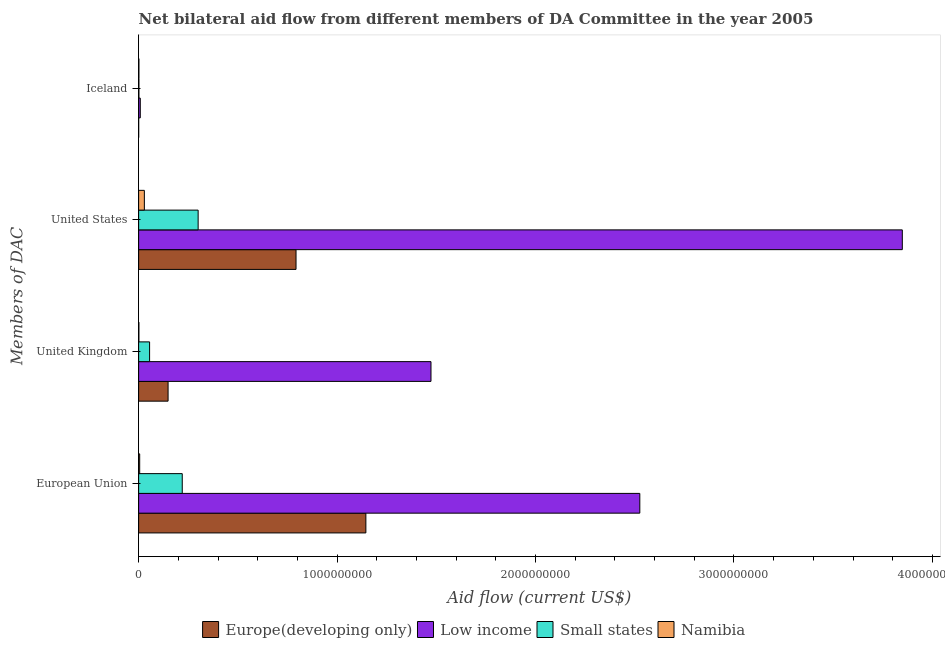What is the amount of aid given by eu in Europe(developing only)?
Offer a very short reply. 1.15e+09. Across all countries, what is the maximum amount of aid given by eu?
Keep it short and to the point. 2.53e+09. Across all countries, what is the minimum amount of aid given by uk?
Provide a short and direct response. 1.29e+06. In which country was the amount of aid given by iceland maximum?
Your answer should be very brief. Low income. In which country was the amount of aid given by eu minimum?
Offer a terse response. Namibia. What is the total amount of aid given by us in the graph?
Ensure brevity in your answer.  4.97e+09. What is the difference between the amount of aid given by us in Namibia and that in Europe(developing only)?
Give a very brief answer. -7.64e+08. What is the difference between the amount of aid given by us in Namibia and the amount of aid given by iceland in Low income?
Offer a very short reply. 2.06e+07. What is the average amount of aid given by us per country?
Make the answer very short. 1.24e+09. What is the difference between the amount of aid given by eu and amount of aid given by us in Namibia?
Make the answer very short. -2.36e+07. What is the ratio of the amount of aid given by us in Europe(developing only) to that in Low income?
Your answer should be very brief. 0.21. What is the difference between the highest and the second highest amount of aid given by eu?
Ensure brevity in your answer.  1.38e+09. What is the difference between the highest and the lowest amount of aid given by uk?
Offer a terse response. 1.47e+09. Is the sum of the amount of aid given by eu in Low income and Small states greater than the maximum amount of aid given by uk across all countries?
Provide a short and direct response. Yes. Is it the case that in every country, the sum of the amount of aid given by eu and amount of aid given by uk is greater than the sum of amount of aid given by iceland and amount of aid given by us?
Your answer should be very brief. No. What does the 1st bar from the top in European Union represents?
Your answer should be very brief. Namibia. What does the 4th bar from the bottom in United Kingdom represents?
Your response must be concise. Namibia. Is it the case that in every country, the sum of the amount of aid given by eu and amount of aid given by uk is greater than the amount of aid given by us?
Provide a short and direct response. No. How many bars are there?
Provide a succinct answer. 16. What is the difference between two consecutive major ticks on the X-axis?
Your answer should be compact. 1.00e+09. Are the values on the major ticks of X-axis written in scientific E-notation?
Provide a short and direct response. No. Where does the legend appear in the graph?
Your response must be concise. Bottom center. How many legend labels are there?
Your answer should be compact. 4. What is the title of the graph?
Your answer should be very brief. Net bilateral aid flow from different members of DA Committee in the year 2005. What is the label or title of the X-axis?
Your answer should be very brief. Aid flow (current US$). What is the label or title of the Y-axis?
Keep it short and to the point. Members of DAC. What is the Aid flow (current US$) in Europe(developing only) in European Union?
Your answer should be compact. 1.15e+09. What is the Aid flow (current US$) in Low income in European Union?
Provide a succinct answer. 2.53e+09. What is the Aid flow (current US$) in Small states in European Union?
Keep it short and to the point. 2.20e+08. What is the Aid flow (current US$) of Namibia in European Union?
Your answer should be very brief. 5.31e+06. What is the Aid flow (current US$) in Europe(developing only) in United Kingdom?
Make the answer very short. 1.48e+08. What is the Aid flow (current US$) in Low income in United Kingdom?
Keep it short and to the point. 1.47e+09. What is the Aid flow (current US$) of Small states in United Kingdom?
Provide a short and direct response. 5.53e+07. What is the Aid flow (current US$) of Namibia in United Kingdom?
Your answer should be very brief. 1.29e+06. What is the Aid flow (current US$) in Europe(developing only) in United States?
Ensure brevity in your answer.  7.93e+08. What is the Aid flow (current US$) in Low income in United States?
Your answer should be very brief. 3.85e+09. What is the Aid flow (current US$) in Small states in United States?
Offer a very short reply. 3.00e+08. What is the Aid flow (current US$) of Namibia in United States?
Offer a terse response. 2.89e+07. What is the Aid flow (current US$) in Europe(developing only) in Iceland?
Offer a terse response. 2.20e+05. What is the Aid flow (current US$) in Low income in Iceland?
Offer a terse response. 8.29e+06. What is the Aid flow (current US$) of Small states in Iceland?
Keep it short and to the point. 1.36e+06. What is the Aid flow (current US$) in Namibia in Iceland?
Keep it short and to the point. 1.36e+06. Across all Members of DAC, what is the maximum Aid flow (current US$) of Europe(developing only)?
Ensure brevity in your answer.  1.15e+09. Across all Members of DAC, what is the maximum Aid flow (current US$) in Low income?
Provide a short and direct response. 3.85e+09. Across all Members of DAC, what is the maximum Aid flow (current US$) of Small states?
Keep it short and to the point. 3.00e+08. Across all Members of DAC, what is the maximum Aid flow (current US$) of Namibia?
Ensure brevity in your answer.  2.89e+07. Across all Members of DAC, what is the minimum Aid flow (current US$) of Europe(developing only)?
Provide a succinct answer. 2.20e+05. Across all Members of DAC, what is the minimum Aid flow (current US$) in Low income?
Your answer should be very brief. 8.29e+06. Across all Members of DAC, what is the minimum Aid flow (current US$) in Small states?
Offer a terse response. 1.36e+06. Across all Members of DAC, what is the minimum Aid flow (current US$) in Namibia?
Ensure brevity in your answer.  1.29e+06. What is the total Aid flow (current US$) of Europe(developing only) in the graph?
Your answer should be compact. 2.09e+09. What is the total Aid flow (current US$) of Low income in the graph?
Provide a short and direct response. 7.86e+09. What is the total Aid flow (current US$) of Small states in the graph?
Keep it short and to the point. 5.76e+08. What is the total Aid flow (current US$) in Namibia in the graph?
Ensure brevity in your answer.  3.68e+07. What is the difference between the Aid flow (current US$) in Europe(developing only) in European Union and that in United Kingdom?
Your answer should be very brief. 9.97e+08. What is the difference between the Aid flow (current US$) in Low income in European Union and that in United Kingdom?
Keep it short and to the point. 1.05e+09. What is the difference between the Aid flow (current US$) in Small states in European Union and that in United Kingdom?
Offer a terse response. 1.65e+08. What is the difference between the Aid flow (current US$) in Namibia in European Union and that in United Kingdom?
Provide a succinct answer. 4.02e+06. What is the difference between the Aid flow (current US$) of Europe(developing only) in European Union and that in United States?
Keep it short and to the point. 3.52e+08. What is the difference between the Aid flow (current US$) of Low income in European Union and that in United States?
Make the answer very short. -1.32e+09. What is the difference between the Aid flow (current US$) of Small states in European Union and that in United States?
Ensure brevity in your answer.  -8.01e+07. What is the difference between the Aid flow (current US$) in Namibia in European Union and that in United States?
Provide a succinct answer. -2.36e+07. What is the difference between the Aid flow (current US$) of Europe(developing only) in European Union and that in Iceland?
Ensure brevity in your answer.  1.14e+09. What is the difference between the Aid flow (current US$) of Low income in European Union and that in Iceland?
Provide a short and direct response. 2.52e+09. What is the difference between the Aid flow (current US$) in Small states in European Union and that in Iceland?
Your answer should be very brief. 2.18e+08. What is the difference between the Aid flow (current US$) of Namibia in European Union and that in Iceland?
Keep it short and to the point. 3.95e+06. What is the difference between the Aid flow (current US$) of Europe(developing only) in United Kingdom and that in United States?
Your answer should be compact. -6.45e+08. What is the difference between the Aid flow (current US$) in Low income in United Kingdom and that in United States?
Provide a succinct answer. -2.38e+09. What is the difference between the Aid flow (current US$) in Small states in United Kingdom and that in United States?
Keep it short and to the point. -2.45e+08. What is the difference between the Aid flow (current US$) in Namibia in United Kingdom and that in United States?
Provide a short and direct response. -2.76e+07. What is the difference between the Aid flow (current US$) of Europe(developing only) in United Kingdom and that in Iceland?
Make the answer very short. 1.48e+08. What is the difference between the Aid flow (current US$) in Low income in United Kingdom and that in Iceland?
Offer a very short reply. 1.46e+09. What is the difference between the Aid flow (current US$) in Small states in United Kingdom and that in Iceland?
Your answer should be very brief. 5.39e+07. What is the difference between the Aid flow (current US$) in Namibia in United Kingdom and that in Iceland?
Provide a succinct answer. -7.00e+04. What is the difference between the Aid flow (current US$) in Europe(developing only) in United States and that in Iceland?
Give a very brief answer. 7.93e+08. What is the difference between the Aid flow (current US$) of Low income in United States and that in Iceland?
Offer a terse response. 3.84e+09. What is the difference between the Aid flow (current US$) in Small states in United States and that in Iceland?
Provide a succinct answer. 2.99e+08. What is the difference between the Aid flow (current US$) in Namibia in United States and that in Iceland?
Keep it short and to the point. 2.75e+07. What is the difference between the Aid flow (current US$) of Europe(developing only) in European Union and the Aid flow (current US$) of Low income in United Kingdom?
Your response must be concise. -3.28e+08. What is the difference between the Aid flow (current US$) in Europe(developing only) in European Union and the Aid flow (current US$) in Small states in United Kingdom?
Offer a terse response. 1.09e+09. What is the difference between the Aid flow (current US$) of Europe(developing only) in European Union and the Aid flow (current US$) of Namibia in United Kingdom?
Offer a very short reply. 1.14e+09. What is the difference between the Aid flow (current US$) in Low income in European Union and the Aid flow (current US$) in Small states in United Kingdom?
Provide a succinct answer. 2.47e+09. What is the difference between the Aid flow (current US$) of Low income in European Union and the Aid flow (current US$) of Namibia in United Kingdom?
Offer a very short reply. 2.52e+09. What is the difference between the Aid flow (current US$) of Small states in European Union and the Aid flow (current US$) of Namibia in United Kingdom?
Provide a short and direct response. 2.19e+08. What is the difference between the Aid flow (current US$) of Europe(developing only) in European Union and the Aid flow (current US$) of Low income in United States?
Offer a terse response. -2.70e+09. What is the difference between the Aid flow (current US$) of Europe(developing only) in European Union and the Aid flow (current US$) of Small states in United States?
Offer a very short reply. 8.45e+08. What is the difference between the Aid flow (current US$) of Europe(developing only) in European Union and the Aid flow (current US$) of Namibia in United States?
Offer a very short reply. 1.12e+09. What is the difference between the Aid flow (current US$) in Low income in European Union and the Aid flow (current US$) in Small states in United States?
Provide a short and direct response. 2.23e+09. What is the difference between the Aid flow (current US$) of Low income in European Union and the Aid flow (current US$) of Namibia in United States?
Make the answer very short. 2.50e+09. What is the difference between the Aid flow (current US$) of Small states in European Union and the Aid flow (current US$) of Namibia in United States?
Ensure brevity in your answer.  1.91e+08. What is the difference between the Aid flow (current US$) in Europe(developing only) in European Union and the Aid flow (current US$) in Low income in Iceland?
Provide a short and direct response. 1.14e+09. What is the difference between the Aid flow (current US$) of Europe(developing only) in European Union and the Aid flow (current US$) of Small states in Iceland?
Keep it short and to the point. 1.14e+09. What is the difference between the Aid flow (current US$) in Europe(developing only) in European Union and the Aid flow (current US$) in Namibia in Iceland?
Give a very brief answer. 1.14e+09. What is the difference between the Aid flow (current US$) of Low income in European Union and the Aid flow (current US$) of Small states in Iceland?
Provide a short and direct response. 2.52e+09. What is the difference between the Aid flow (current US$) of Low income in European Union and the Aid flow (current US$) of Namibia in Iceland?
Your response must be concise. 2.52e+09. What is the difference between the Aid flow (current US$) of Small states in European Union and the Aid flow (current US$) of Namibia in Iceland?
Provide a succinct answer. 2.18e+08. What is the difference between the Aid flow (current US$) of Europe(developing only) in United Kingdom and the Aid flow (current US$) of Low income in United States?
Give a very brief answer. -3.70e+09. What is the difference between the Aid flow (current US$) in Europe(developing only) in United Kingdom and the Aid flow (current US$) in Small states in United States?
Keep it short and to the point. -1.52e+08. What is the difference between the Aid flow (current US$) in Europe(developing only) in United Kingdom and the Aid flow (current US$) in Namibia in United States?
Give a very brief answer. 1.20e+08. What is the difference between the Aid flow (current US$) of Low income in United Kingdom and the Aid flow (current US$) of Small states in United States?
Give a very brief answer. 1.17e+09. What is the difference between the Aid flow (current US$) in Low income in United Kingdom and the Aid flow (current US$) in Namibia in United States?
Ensure brevity in your answer.  1.44e+09. What is the difference between the Aid flow (current US$) in Small states in United Kingdom and the Aid flow (current US$) in Namibia in United States?
Offer a terse response. 2.64e+07. What is the difference between the Aid flow (current US$) of Europe(developing only) in United Kingdom and the Aid flow (current US$) of Low income in Iceland?
Your answer should be compact. 1.40e+08. What is the difference between the Aid flow (current US$) of Europe(developing only) in United Kingdom and the Aid flow (current US$) of Small states in Iceland?
Your response must be concise. 1.47e+08. What is the difference between the Aid flow (current US$) in Europe(developing only) in United Kingdom and the Aid flow (current US$) in Namibia in Iceland?
Your answer should be very brief. 1.47e+08. What is the difference between the Aid flow (current US$) of Low income in United Kingdom and the Aid flow (current US$) of Small states in Iceland?
Your response must be concise. 1.47e+09. What is the difference between the Aid flow (current US$) of Low income in United Kingdom and the Aid flow (current US$) of Namibia in Iceland?
Offer a terse response. 1.47e+09. What is the difference between the Aid flow (current US$) of Small states in United Kingdom and the Aid flow (current US$) of Namibia in Iceland?
Your answer should be very brief. 5.39e+07. What is the difference between the Aid flow (current US$) in Europe(developing only) in United States and the Aid flow (current US$) in Low income in Iceland?
Offer a terse response. 7.85e+08. What is the difference between the Aid flow (current US$) in Europe(developing only) in United States and the Aid flow (current US$) in Small states in Iceland?
Ensure brevity in your answer.  7.92e+08. What is the difference between the Aid flow (current US$) in Europe(developing only) in United States and the Aid flow (current US$) in Namibia in Iceland?
Offer a very short reply. 7.92e+08. What is the difference between the Aid flow (current US$) in Low income in United States and the Aid flow (current US$) in Small states in Iceland?
Your answer should be compact. 3.85e+09. What is the difference between the Aid flow (current US$) in Low income in United States and the Aid flow (current US$) in Namibia in Iceland?
Offer a terse response. 3.85e+09. What is the difference between the Aid flow (current US$) of Small states in United States and the Aid flow (current US$) of Namibia in Iceland?
Your answer should be very brief. 2.99e+08. What is the average Aid flow (current US$) of Europe(developing only) per Members of DAC?
Your answer should be compact. 5.22e+08. What is the average Aid flow (current US$) of Low income per Members of DAC?
Provide a succinct answer. 1.96e+09. What is the average Aid flow (current US$) of Small states per Members of DAC?
Provide a short and direct response. 1.44e+08. What is the average Aid flow (current US$) of Namibia per Members of DAC?
Provide a short and direct response. 9.21e+06. What is the difference between the Aid flow (current US$) of Europe(developing only) and Aid flow (current US$) of Low income in European Union?
Provide a short and direct response. -1.38e+09. What is the difference between the Aid flow (current US$) in Europe(developing only) and Aid flow (current US$) in Small states in European Union?
Offer a terse response. 9.25e+08. What is the difference between the Aid flow (current US$) of Europe(developing only) and Aid flow (current US$) of Namibia in European Union?
Your answer should be compact. 1.14e+09. What is the difference between the Aid flow (current US$) in Low income and Aid flow (current US$) in Small states in European Union?
Your answer should be very brief. 2.31e+09. What is the difference between the Aid flow (current US$) in Low income and Aid flow (current US$) in Namibia in European Union?
Provide a short and direct response. 2.52e+09. What is the difference between the Aid flow (current US$) in Small states and Aid flow (current US$) in Namibia in European Union?
Ensure brevity in your answer.  2.14e+08. What is the difference between the Aid flow (current US$) of Europe(developing only) and Aid flow (current US$) of Low income in United Kingdom?
Provide a short and direct response. -1.32e+09. What is the difference between the Aid flow (current US$) of Europe(developing only) and Aid flow (current US$) of Small states in United Kingdom?
Ensure brevity in your answer.  9.32e+07. What is the difference between the Aid flow (current US$) in Europe(developing only) and Aid flow (current US$) in Namibia in United Kingdom?
Keep it short and to the point. 1.47e+08. What is the difference between the Aid flow (current US$) of Low income and Aid flow (current US$) of Small states in United Kingdom?
Your response must be concise. 1.42e+09. What is the difference between the Aid flow (current US$) in Low income and Aid flow (current US$) in Namibia in United Kingdom?
Give a very brief answer. 1.47e+09. What is the difference between the Aid flow (current US$) in Small states and Aid flow (current US$) in Namibia in United Kingdom?
Your answer should be very brief. 5.40e+07. What is the difference between the Aid flow (current US$) of Europe(developing only) and Aid flow (current US$) of Low income in United States?
Provide a succinct answer. -3.06e+09. What is the difference between the Aid flow (current US$) of Europe(developing only) and Aid flow (current US$) of Small states in United States?
Keep it short and to the point. 4.93e+08. What is the difference between the Aid flow (current US$) of Europe(developing only) and Aid flow (current US$) of Namibia in United States?
Make the answer very short. 7.64e+08. What is the difference between the Aid flow (current US$) in Low income and Aid flow (current US$) in Small states in United States?
Keep it short and to the point. 3.55e+09. What is the difference between the Aid flow (current US$) in Low income and Aid flow (current US$) in Namibia in United States?
Give a very brief answer. 3.82e+09. What is the difference between the Aid flow (current US$) in Small states and Aid flow (current US$) in Namibia in United States?
Make the answer very short. 2.71e+08. What is the difference between the Aid flow (current US$) of Europe(developing only) and Aid flow (current US$) of Low income in Iceland?
Provide a succinct answer. -8.07e+06. What is the difference between the Aid flow (current US$) of Europe(developing only) and Aid flow (current US$) of Small states in Iceland?
Provide a succinct answer. -1.14e+06. What is the difference between the Aid flow (current US$) in Europe(developing only) and Aid flow (current US$) in Namibia in Iceland?
Give a very brief answer. -1.14e+06. What is the difference between the Aid flow (current US$) of Low income and Aid flow (current US$) of Small states in Iceland?
Your answer should be compact. 6.93e+06. What is the difference between the Aid flow (current US$) in Low income and Aid flow (current US$) in Namibia in Iceland?
Your response must be concise. 6.93e+06. What is the difference between the Aid flow (current US$) of Small states and Aid flow (current US$) of Namibia in Iceland?
Ensure brevity in your answer.  0. What is the ratio of the Aid flow (current US$) of Europe(developing only) in European Union to that in United Kingdom?
Your answer should be compact. 7.72. What is the ratio of the Aid flow (current US$) in Low income in European Union to that in United Kingdom?
Keep it short and to the point. 1.71. What is the ratio of the Aid flow (current US$) of Small states in European Union to that in United Kingdom?
Keep it short and to the point. 3.98. What is the ratio of the Aid flow (current US$) of Namibia in European Union to that in United Kingdom?
Provide a succinct answer. 4.12. What is the ratio of the Aid flow (current US$) of Europe(developing only) in European Union to that in United States?
Provide a succinct answer. 1.44. What is the ratio of the Aid flow (current US$) in Low income in European Union to that in United States?
Offer a very short reply. 0.66. What is the ratio of the Aid flow (current US$) in Small states in European Union to that in United States?
Your answer should be very brief. 0.73. What is the ratio of the Aid flow (current US$) of Namibia in European Union to that in United States?
Offer a very short reply. 0.18. What is the ratio of the Aid flow (current US$) of Europe(developing only) in European Union to that in Iceland?
Your response must be concise. 5205.27. What is the ratio of the Aid flow (current US$) of Low income in European Union to that in Iceland?
Your response must be concise. 304.65. What is the ratio of the Aid flow (current US$) of Small states in European Union to that in Iceland?
Your answer should be very brief. 161.62. What is the ratio of the Aid flow (current US$) of Namibia in European Union to that in Iceland?
Provide a succinct answer. 3.9. What is the ratio of the Aid flow (current US$) in Europe(developing only) in United Kingdom to that in United States?
Offer a very short reply. 0.19. What is the ratio of the Aid flow (current US$) in Low income in United Kingdom to that in United States?
Your answer should be very brief. 0.38. What is the ratio of the Aid flow (current US$) of Small states in United Kingdom to that in United States?
Your response must be concise. 0.18. What is the ratio of the Aid flow (current US$) of Namibia in United Kingdom to that in United States?
Offer a very short reply. 0.04. What is the ratio of the Aid flow (current US$) in Europe(developing only) in United Kingdom to that in Iceland?
Ensure brevity in your answer.  674.68. What is the ratio of the Aid flow (current US$) of Low income in United Kingdom to that in Iceland?
Give a very brief answer. 177.71. What is the ratio of the Aid flow (current US$) of Small states in United Kingdom to that in Iceland?
Ensure brevity in your answer.  40.65. What is the ratio of the Aid flow (current US$) in Namibia in United Kingdom to that in Iceland?
Offer a very short reply. 0.95. What is the ratio of the Aid flow (current US$) in Europe(developing only) in United States to that in Iceland?
Offer a very short reply. 3605.23. What is the ratio of the Aid flow (current US$) of Low income in United States to that in Iceland?
Ensure brevity in your answer.  464.21. What is the ratio of the Aid flow (current US$) in Small states in United States to that in Iceland?
Offer a terse response. 220.54. What is the ratio of the Aid flow (current US$) in Namibia in United States to that in Iceland?
Your answer should be compact. 21.23. What is the difference between the highest and the second highest Aid flow (current US$) of Europe(developing only)?
Provide a succinct answer. 3.52e+08. What is the difference between the highest and the second highest Aid flow (current US$) in Low income?
Your answer should be very brief. 1.32e+09. What is the difference between the highest and the second highest Aid flow (current US$) in Small states?
Provide a short and direct response. 8.01e+07. What is the difference between the highest and the second highest Aid flow (current US$) of Namibia?
Provide a succinct answer. 2.36e+07. What is the difference between the highest and the lowest Aid flow (current US$) in Europe(developing only)?
Offer a very short reply. 1.14e+09. What is the difference between the highest and the lowest Aid flow (current US$) of Low income?
Offer a very short reply. 3.84e+09. What is the difference between the highest and the lowest Aid flow (current US$) in Small states?
Make the answer very short. 2.99e+08. What is the difference between the highest and the lowest Aid flow (current US$) of Namibia?
Your response must be concise. 2.76e+07. 